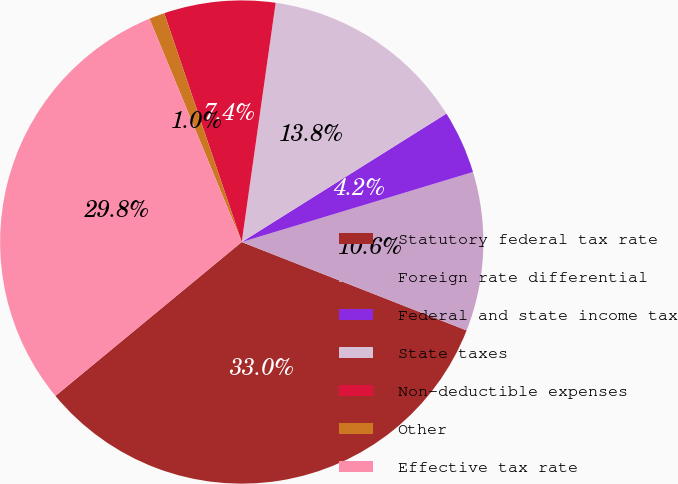Convert chart. <chart><loc_0><loc_0><loc_500><loc_500><pie_chart><fcel>Statutory federal tax rate<fcel>Foreign rate differential<fcel>Federal and state income tax<fcel>State taxes<fcel>Non-deductible expenses<fcel>Other<fcel>Effective tax rate<nl><fcel>33.05%<fcel>10.64%<fcel>4.24%<fcel>13.84%<fcel>7.44%<fcel>1.04%<fcel>29.75%<nl></chart> 